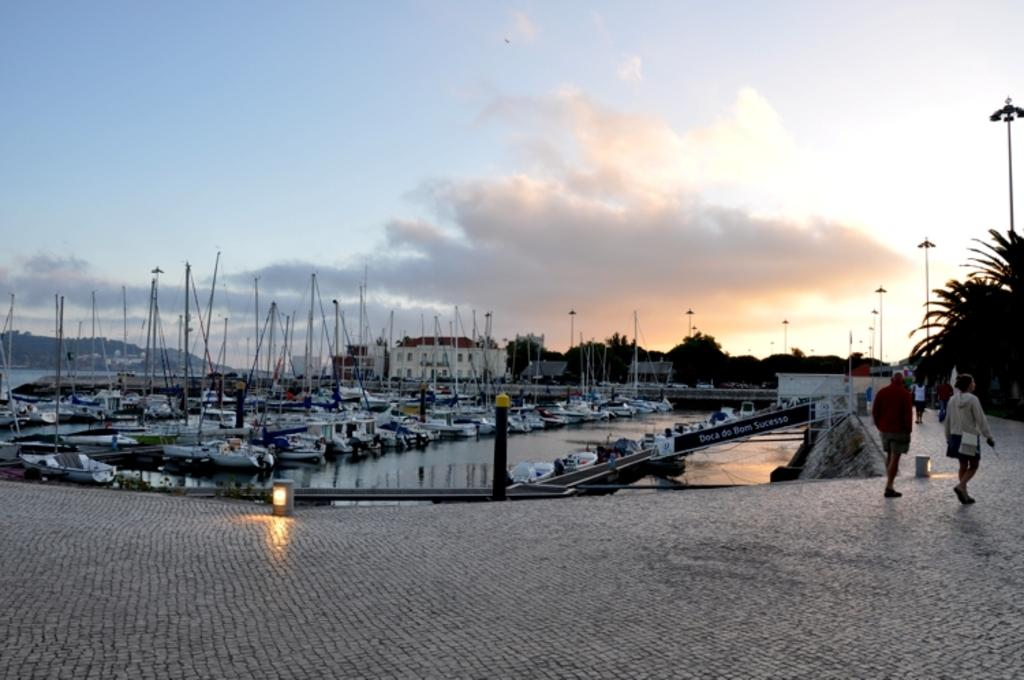What is in the foreground of the image? There is a path in the foreground of the image. What are the people in the image doing? There are people walking on the path. What can be seen in the background of the image? Boats on the water, poles, trees, and the sky are visible in the background of the image. What is the condition of the sky in the image? The sky is visible in the background of the image, and there are clouds present. Where is the sister sitting in the lunchroom in the image? There is no sister or lunchroom present in the image. What type of power is being generated by the boats in the image? The boats in the image are not generating any power; they are simply floating on the water. 